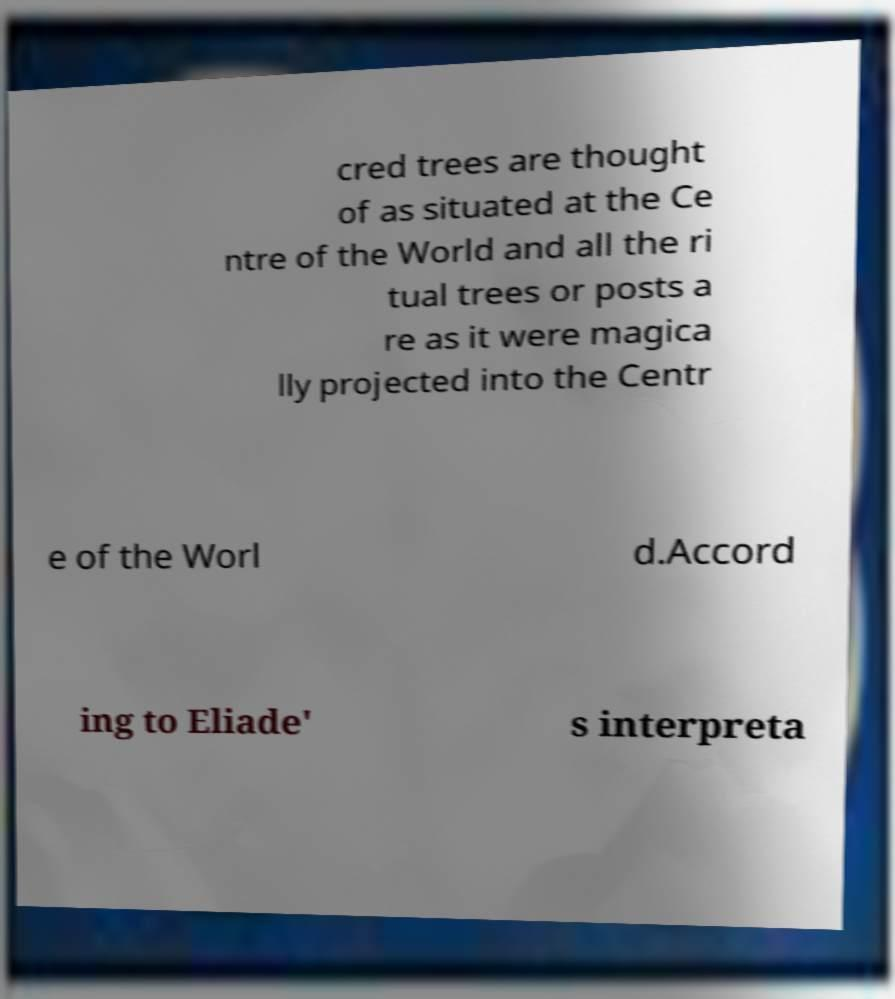For documentation purposes, I need the text within this image transcribed. Could you provide that? cred trees are thought of as situated at the Ce ntre of the World and all the ri tual trees or posts a re as it were magica lly projected into the Centr e of the Worl d.Accord ing to Eliade' s interpreta 